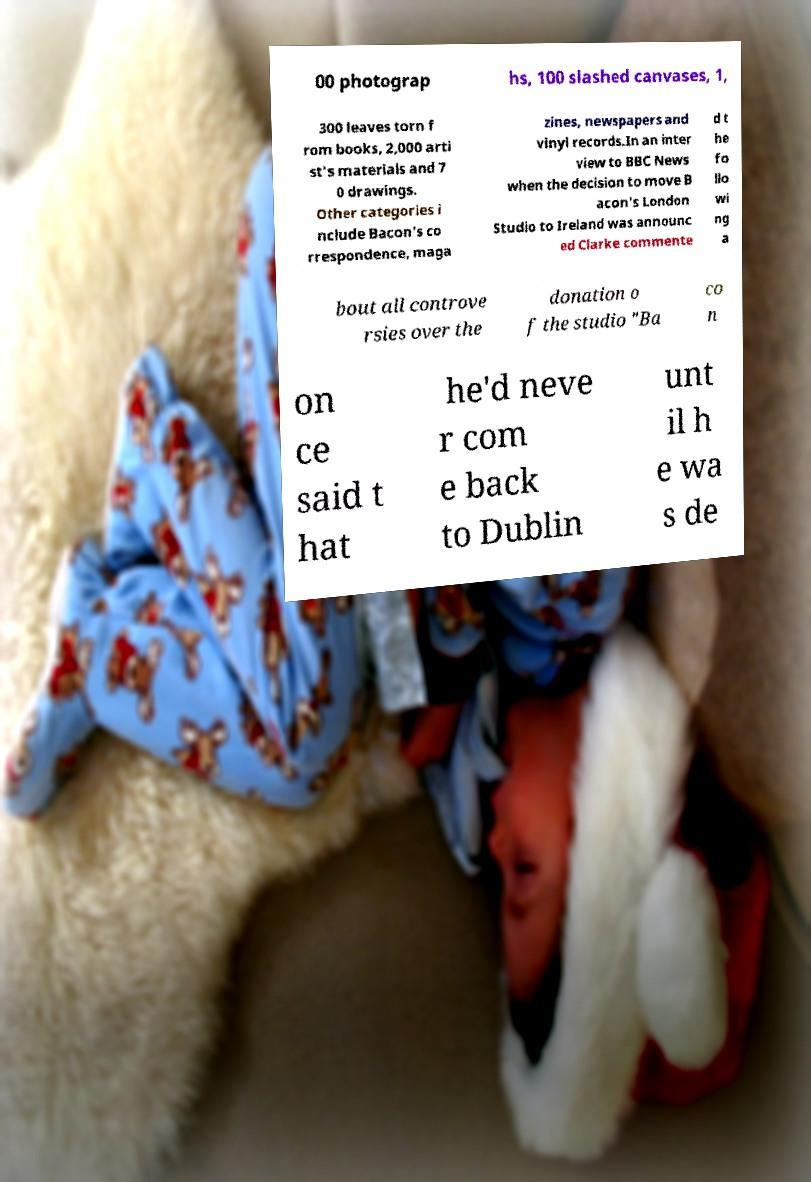Could you extract and type out the text from this image? 00 photograp hs, 100 slashed canvases, 1, 300 leaves torn f rom books, 2,000 arti st's materials and 7 0 drawings. Other categories i nclude Bacon's co rrespondence, maga zines, newspapers and vinyl records.In an inter view to BBC News when the decision to move B acon's London Studio to Ireland was announc ed Clarke commente d t he fo llo wi ng a bout all controve rsies over the donation o f the studio "Ba co n on ce said t hat he'd neve r com e back to Dublin unt il h e wa s de 